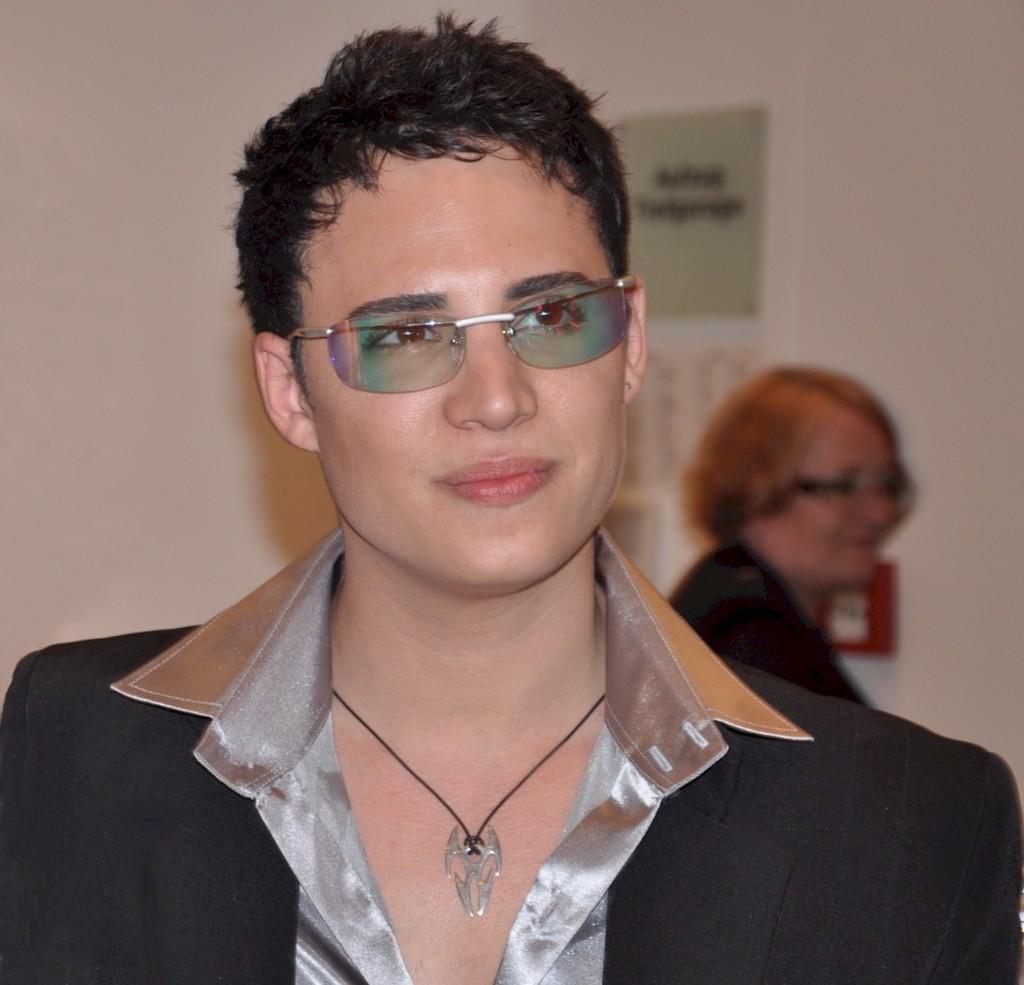Describe this image in one or two sentences. In this image we can see a person wearing black blazer, spectacles and chain is standing here and smiling. The background of the image is blurred, where we can see a woman and the wall. 